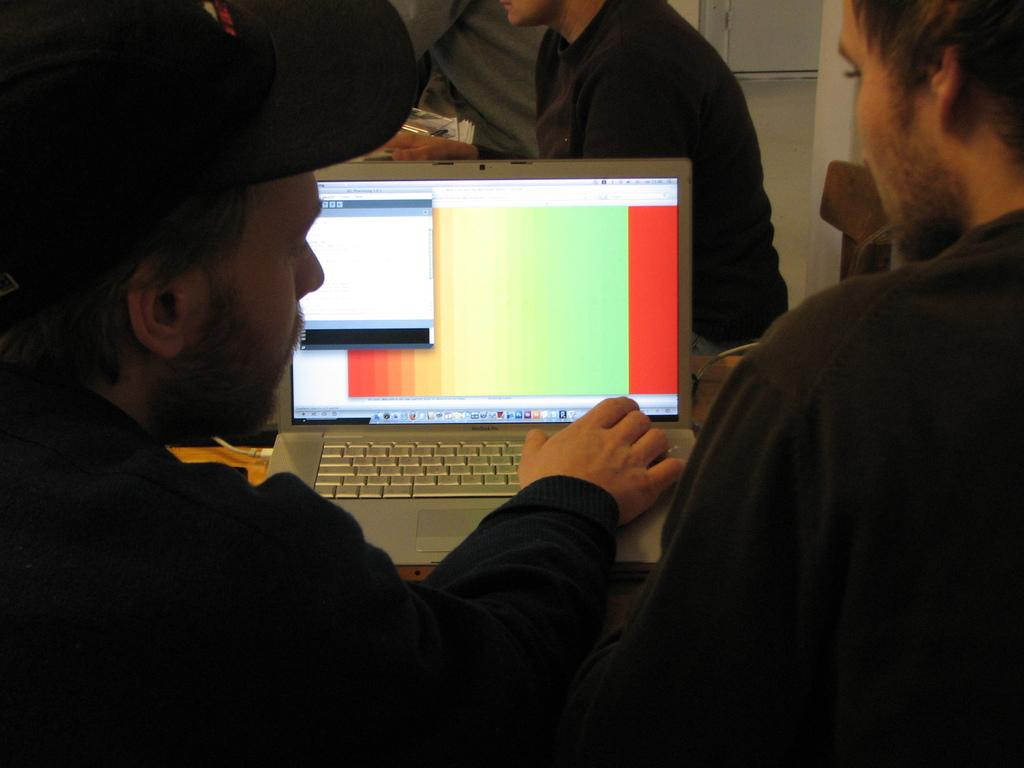How many people are in the image? There are four persons in the image. What electronic device can be seen in the image? There is a laptop in the image. What is visible on the laptop screen? The laptop has two windows open. What type of background can be seen in the image? There is a wall visible in the image. What type of furniture is present in the image? There is a chair in the image. What type of branch is being used to hook the laptop in the image? There is no branch or hook present in the image; the laptop is not being held or suspended in any way. 